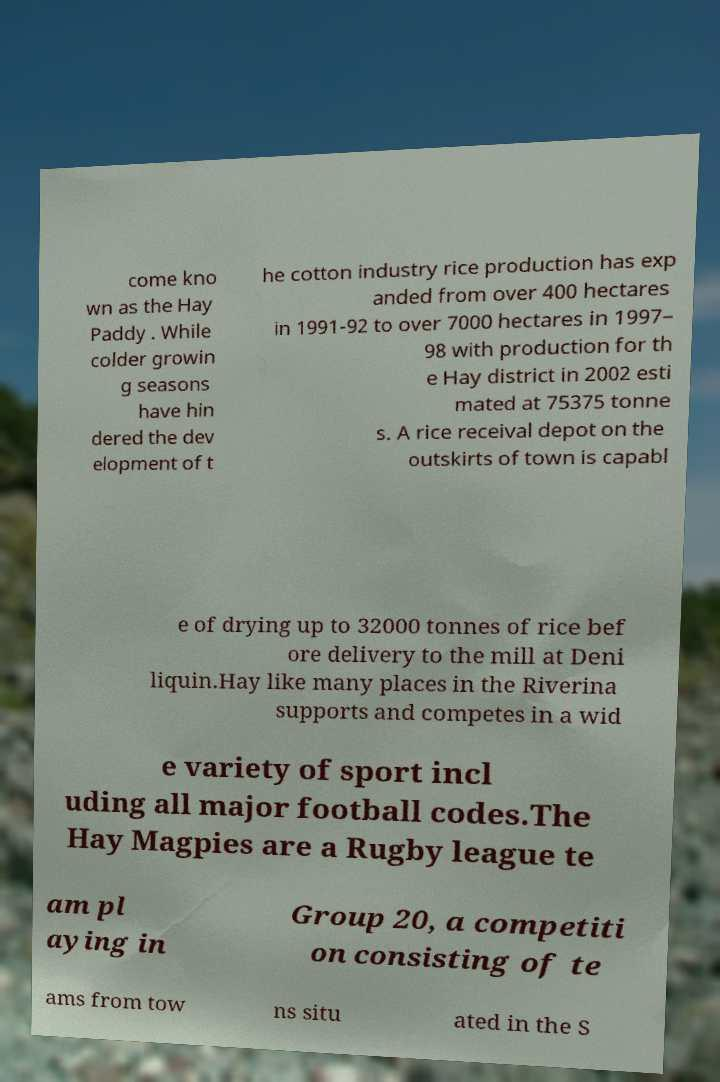For documentation purposes, I need the text within this image transcribed. Could you provide that? come kno wn as the Hay Paddy . While colder growin g seasons have hin dered the dev elopment of t he cotton industry rice production has exp anded from over 400 hectares in 1991-92 to over 7000 hectares in 1997– 98 with production for th e Hay district in 2002 esti mated at 75375 tonne s. A rice receival depot on the outskirts of town is capabl e of drying up to 32000 tonnes of rice bef ore delivery to the mill at Deni liquin.Hay like many places in the Riverina supports and competes in a wid e variety of sport incl uding all major football codes.The Hay Magpies are a Rugby league te am pl aying in Group 20, a competiti on consisting of te ams from tow ns situ ated in the S 